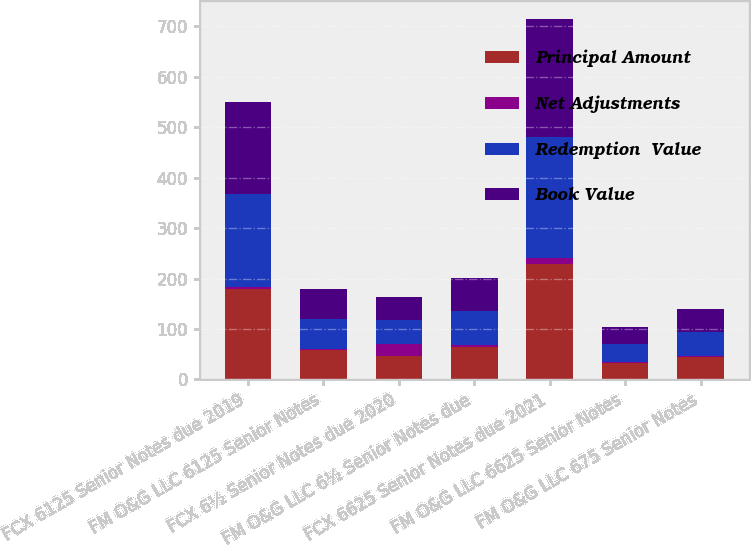Convert chart. <chart><loc_0><loc_0><loc_500><loc_500><stacked_bar_chart><ecel><fcel>FCX 6125 Senior Notes due 2019<fcel>FM O&G LLC 6125 Senior Notes<fcel>FCX 6½ Senior Notes due 2020<fcel>FM O&G LLC 6½ Senior Notes due<fcel>FCX 6625 Senior Notes due 2021<fcel>FM O&G LLC 6625 Senior Notes<fcel>FM O&G LLC 675 Senior Notes<nl><fcel>Principal Amount<fcel>179<fcel>58<fcel>47<fcel>65<fcel>228<fcel>33<fcel>45<nl><fcel>Net Adjustments<fcel>5<fcel>2<fcel>23<fcel>3<fcel>12<fcel>2<fcel>2<nl><fcel>Redemption  Value<fcel>184<fcel>60<fcel>47<fcel>68<fcel>240<fcel>35<fcel>47<nl><fcel>Book Value<fcel>182<fcel>59<fcel>47<fcel>66<fcel>234<fcel>34<fcel>46<nl></chart> 